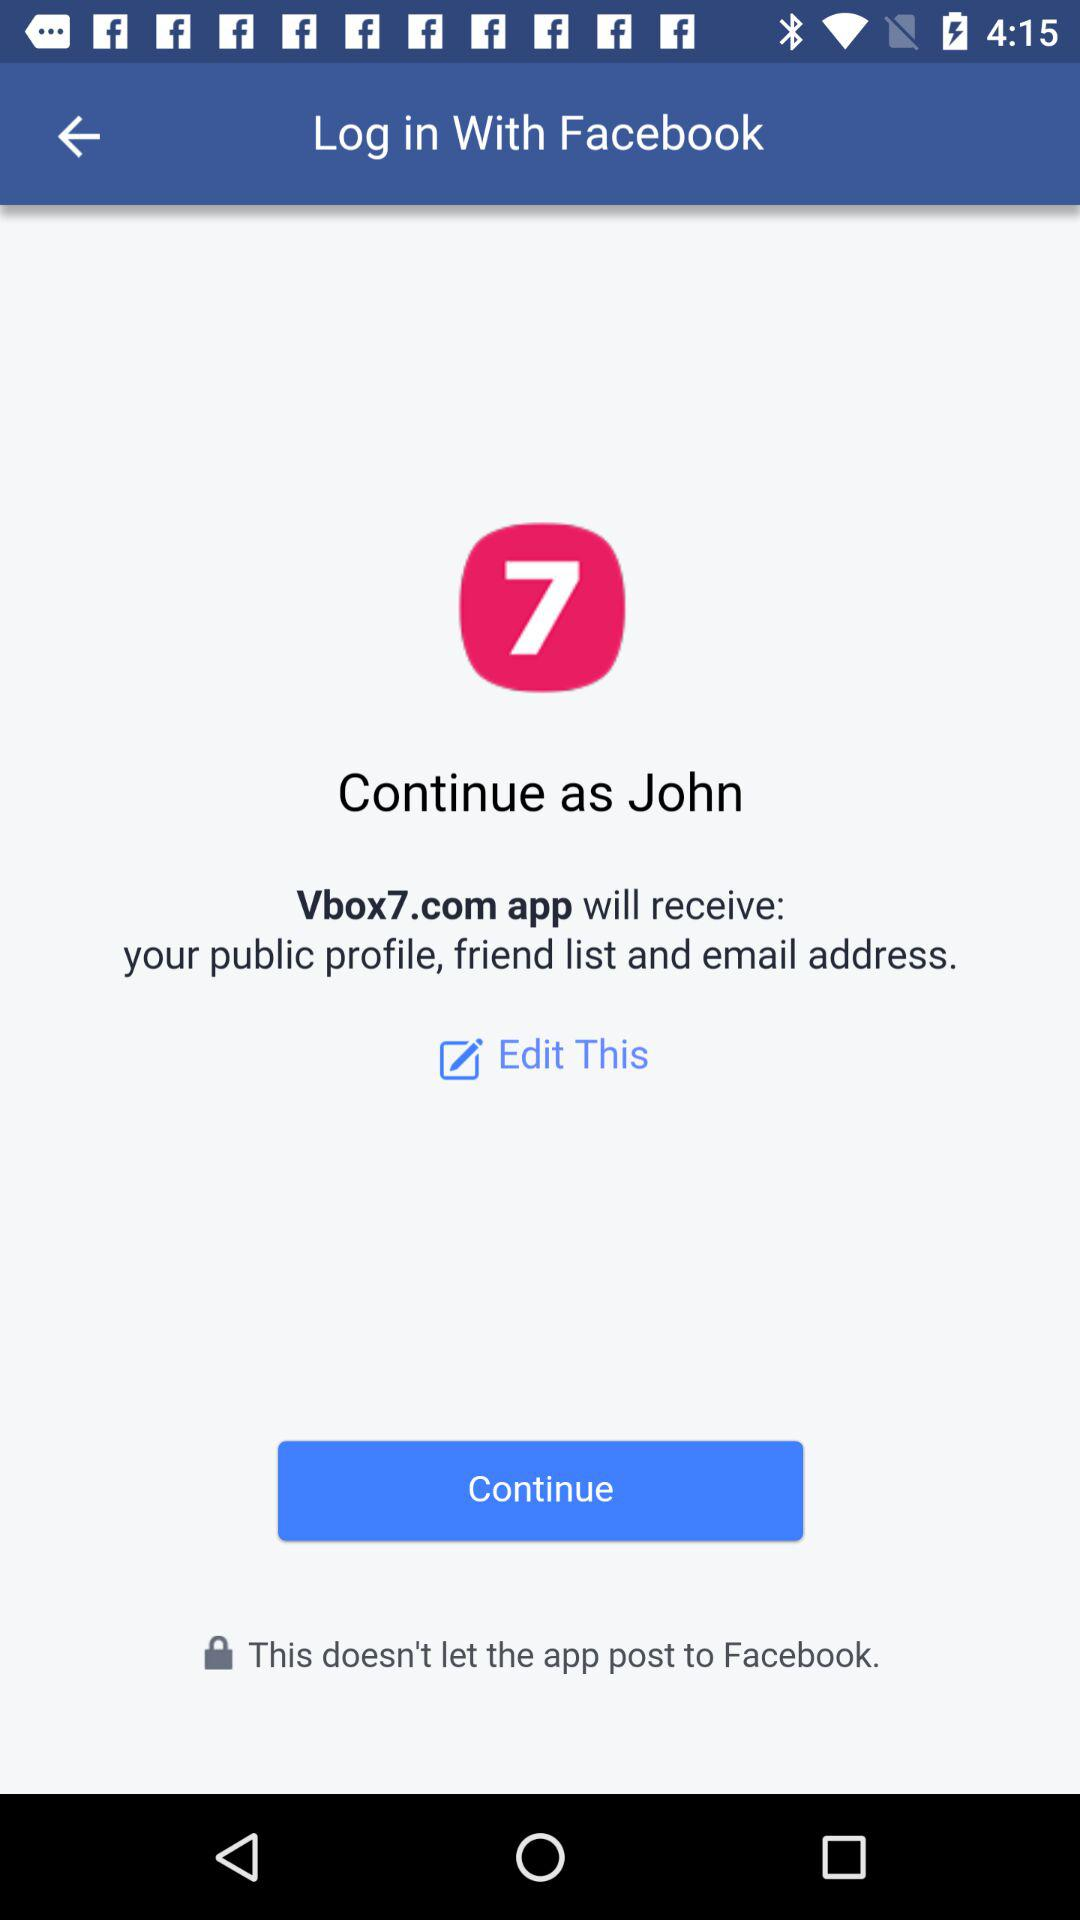What account am I using for login? The account is "Facebook". 